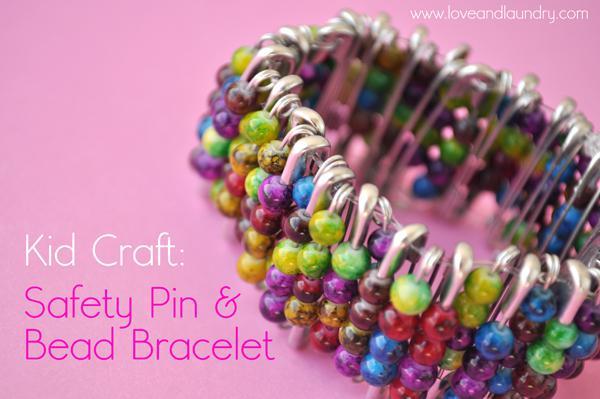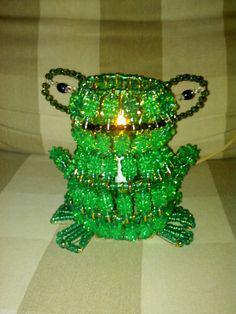The first image is the image on the left, the second image is the image on the right. For the images shown, is this caption "At least one of the images displays a pin with a heart pennant." true? Answer yes or no. No. The first image is the image on the left, the second image is the image on the right. Analyze the images presented: Is the assertion "An image includes a pin jewelry creation with beads that form a heart shape." valid? Answer yes or no. No. 